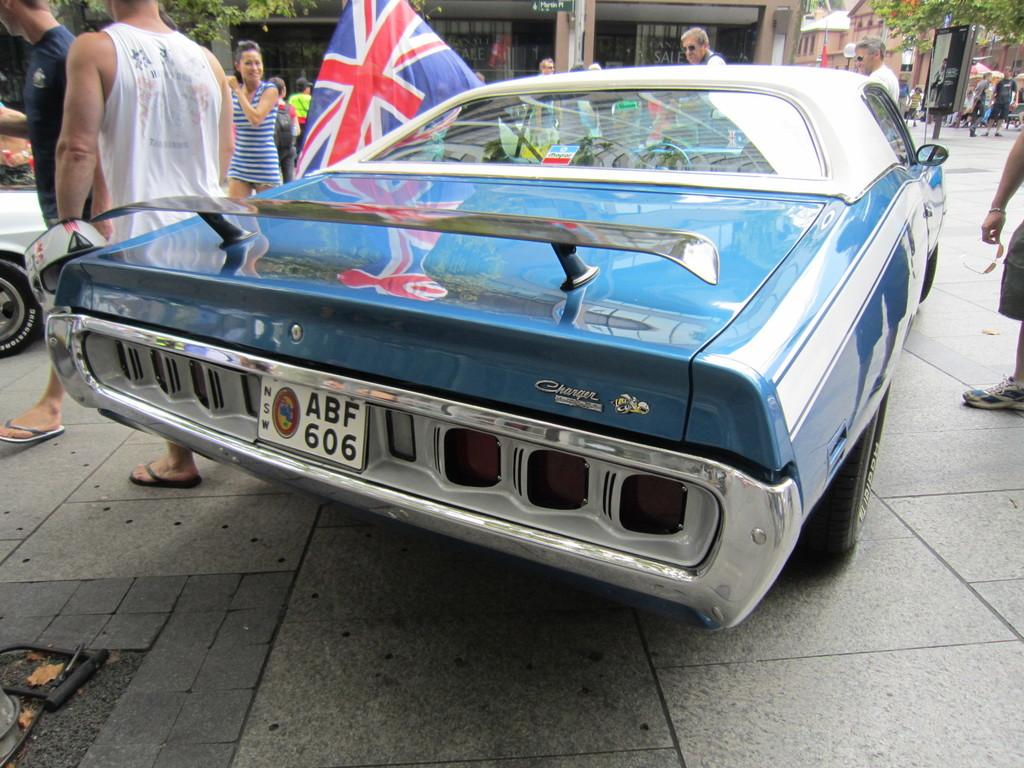Provide a one-sentence caption for the provided image. The funky blue car has the registration ABF 606. 